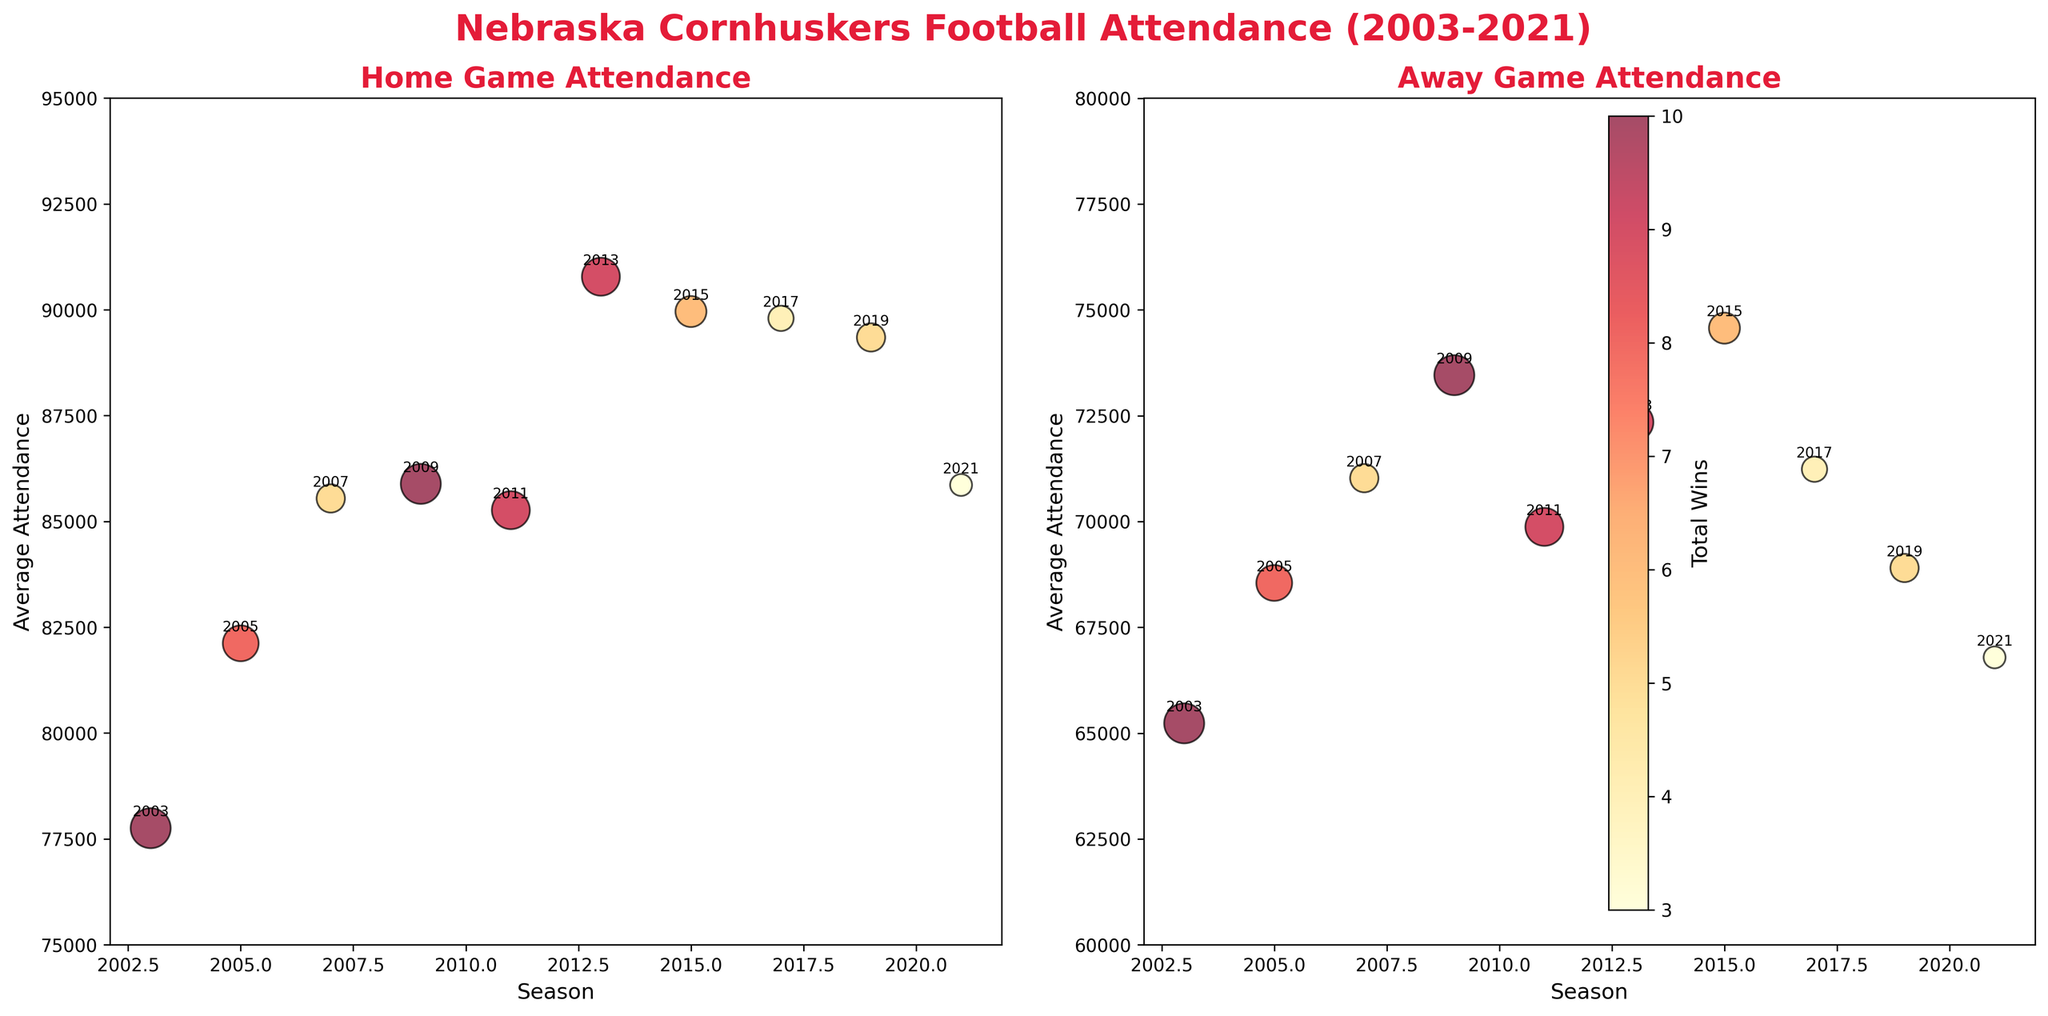What is the title of the subplot on the left? The title of each subplot is located at the top of each chart. For the left subplot, it reads "Home Game Attendance".
Answer: Home Game Attendance What is the minimum average attendance shown for home games in any season? Observing the y-axis for home game attendance and the data points, the minimum value is around 77,754.
Answer: 77,754 How many seasons had an average home attendance over 85,000? Counting the data points above the 85,000 line in the left subplot, four seasons had average home attendance over 85,000.
Answer: 4 Which season had the highest number of wins? Looking for the largest bubbles in both subplots, the season 2003 had the highest wins, represented by the largest bubbles.
Answer: 2003 In which season was the average away attendance the lowest? Observing the position of the lowest data point in the right subplot (away attendance), the 2021 season had the lowest away attendance.
Answer: 2021 Which season had the highest average away attendance? Observing the position of the highest data point in the right subplot, the 2015 season had the highest away attendance.
Answer: 2015 Compare the home and away attendance in the 2013 season. Which was higher and by how much? For the 2013 season, the home attendance was 90,782, and the away attendance was 72,345, resulting in a difference of 18,437 in favor of home attendance.
Answer: Home by 18,437 Which subplot shows a higher overall range in attendance? By comparing the y-axes, the left subplot (home attendance) ranges from 77,754 to 90,782, and the right subplot (away attendance) ranges from 66,789 to 74,567. The home attendance range is larger.
Answer: Home Attendance Which seasons had no bowl game appearances? The annotations and bubble sizes in both subplots indicate that the 2007, 2017, 2019, and 2021 seasons had no bowl game annotations.
Answer: 2007, 2017, 2019, 2021 In which subplot are the bubbles denoting fewer wins larger compared to the other subplot? Observing the size variations, bubbles in both subplots have similar sizes for matching seasons and wins. There isn't a subplot where bubbles are comparatively larger for fewer wins.
Answer: None 